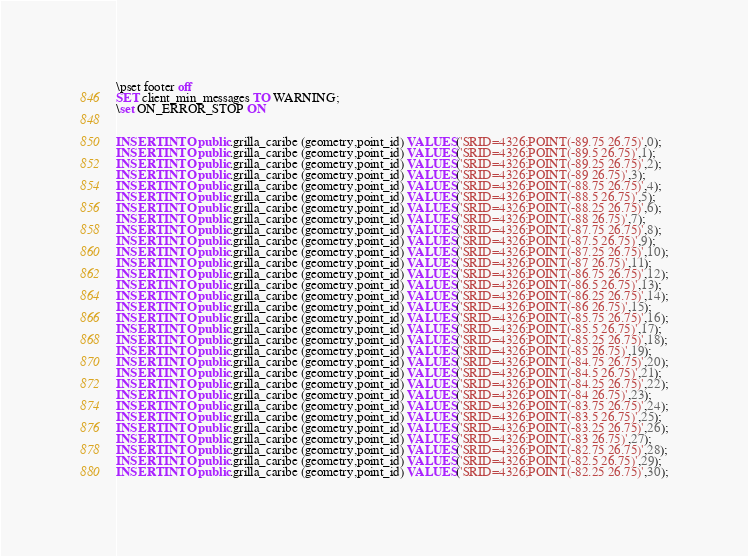<code> <loc_0><loc_0><loc_500><loc_500><_SQL_>\pset footer off
SET client_min_messages TO WARNING;
\set ON_ERROR_STOP ON


INSERT INTO public.grilla_caribe (geometry,point_id) VALUES('SRID=4326;POINT(-89.75 26.75)',0);
INSERT INTO public.grilla_caribe (geometry,point_id) VALUES('SRID=4326;POINT(-89.5 26.75)',1);
INSERT INTO public.grilla_caribe (geometry,point_id) VALUES('SRID=4326;POINT(-89.25 26.75)',2);
INSERT INTO public.grilla_caribe (geometry,point_id) VALUES('SRID=4326;POINT(-89 26.75)',3);
INSERT INTO public.grilla_caribe (geometry,point_id) VALUES('SRID=4326;POINT(-88.75 26.75)',4);
INSERT INTO public.grilla_caribe (geometry,point_id) VALUES('SRID=4326;POINT(-88.5 26.75)',5);
INSERT INTO public.grilla_caribe (geometry,point_id) VALUES('SRID=4326;POINT(-88.25 26.75)',6);
INSERT INTO public.grilla_caribe (geometry,point_id) VALUES('SRID=4326;POINT(-88 26.75)',7);
INSERT INTO public.grilla_caribe (geometry,point_id) VALUES('SRID=4326;POINT(-87.75 26.75)',8);
INSERT INTO public.grilla_caribe (geometry,point_id) VALUES('SRID=4326;POINT(-87.5 26.75)',9);
INSERT INTO public.grilla_caribe (geometry,point_id) VALUES('SRID=4326;POINT(-87.25 26.75)',10);
INSERT INTO public.grilla_caribe (geometry,point_id) VALUES('SRID=4326;POINT(-87 26.75)',11);
INSERT INTO public.grilla_caribe (geometry,point_id) VALUES('SRID=4326;POINT(-86.75 26.75)',12);
INSERT INTO public.grilla_caribe (geometry,point_id) VALUES('SRID=4326;POINT(-86.5 26.75)',13);
INSERT INTO public.grilla_caribe (geometry,point_id) VALUES('SRID=4326;POINT(-86.25 26.75)',14);
INSERT INTO public.grilla_caribe (geometry,point_id) VALUES('SRID=4326;POINT(-86 26.75)',15);
INSERT INTO public.grilla_caribe (geometry,point_id) VALUES('SRID=4326;POINT(-85.75 26.75)',16);
INSERT INTO public.grilla_caribe (geometry,point_id) VALUES('SRID=4326;POINT(-85.5 26.75)',17);
INSERT INTO public.grilla_caribe (geometry,point_id) VALUES('SRID=4326;POINT(-85.25 26.75)',18);
INSERT INTO public.grilla_caribe (geometry,point_id) VALUES('SRID=4326;POINT(-85 26.75)',19);
INSERT INTO public.grilla_caribe (geometry,point_id) VALUES('SRID=4326;POINT(-84.75 26.75)',20);
INSERT INTO public.grilla_caribe (geometry,point_id) VALUES('SRID=4326;POINT(-84.5 26.75)',21);
INSERT INTO public.grilla_caribe (geometry,point_id) VALUES('SRID=4326;POINT(-84.25 26.75)',22);
INSERT INTO public.grilla_caribe (geometry,point_id) VALUES('SRID=4326;POINT(-84 26.75)',23);
INSERT INTO public.grilla_caribe (geometry,point_id) VALUES('SRID=4326;POINT(-83.75 26.75)',24);
INSERT INTO public.grilla_caribe (geometry,point_id) VALUES('SRID=4326;POINT(-83.5 26.75)',25);
INSERT INTO public.grilla_caribe (geometry,point_id) VALUES('SRID=4326;POINT(-83.25 26.75)',26);
INSERT INTO public.grilla_caribe (geometry,point_id) VALUES('SRID=4326;POINT(-83 26.75)',27);
INSERT INTO public.grilla_caribe (geometry,point_id) VALUES('SRID=4326;POINT(-82.75 26.75)',28);
INSERT INTO public.grilla_caribe (geometry,point_id) VALUES('SRID=4326;POINT(-82.5 26.75)',29);
INSERT INTO public.grilla_caribe (geometry,point_id) VALUES('SRID=4326;POINT(-82.25 26.75)',30);</code> 